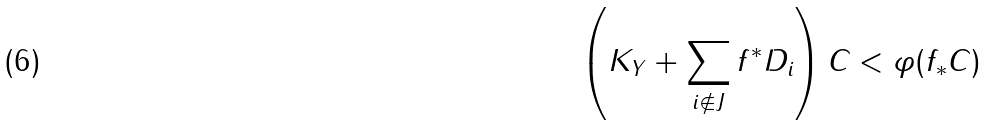Convert formula to latex. <formula><loc_0><loc_0><loc_500><loc_500>\left ( K _ { Y } + \sum _ { i \not \in J } f ^ { * } D _ { i } \right ) C < \varphi ( f _ { * } C )</formula> 